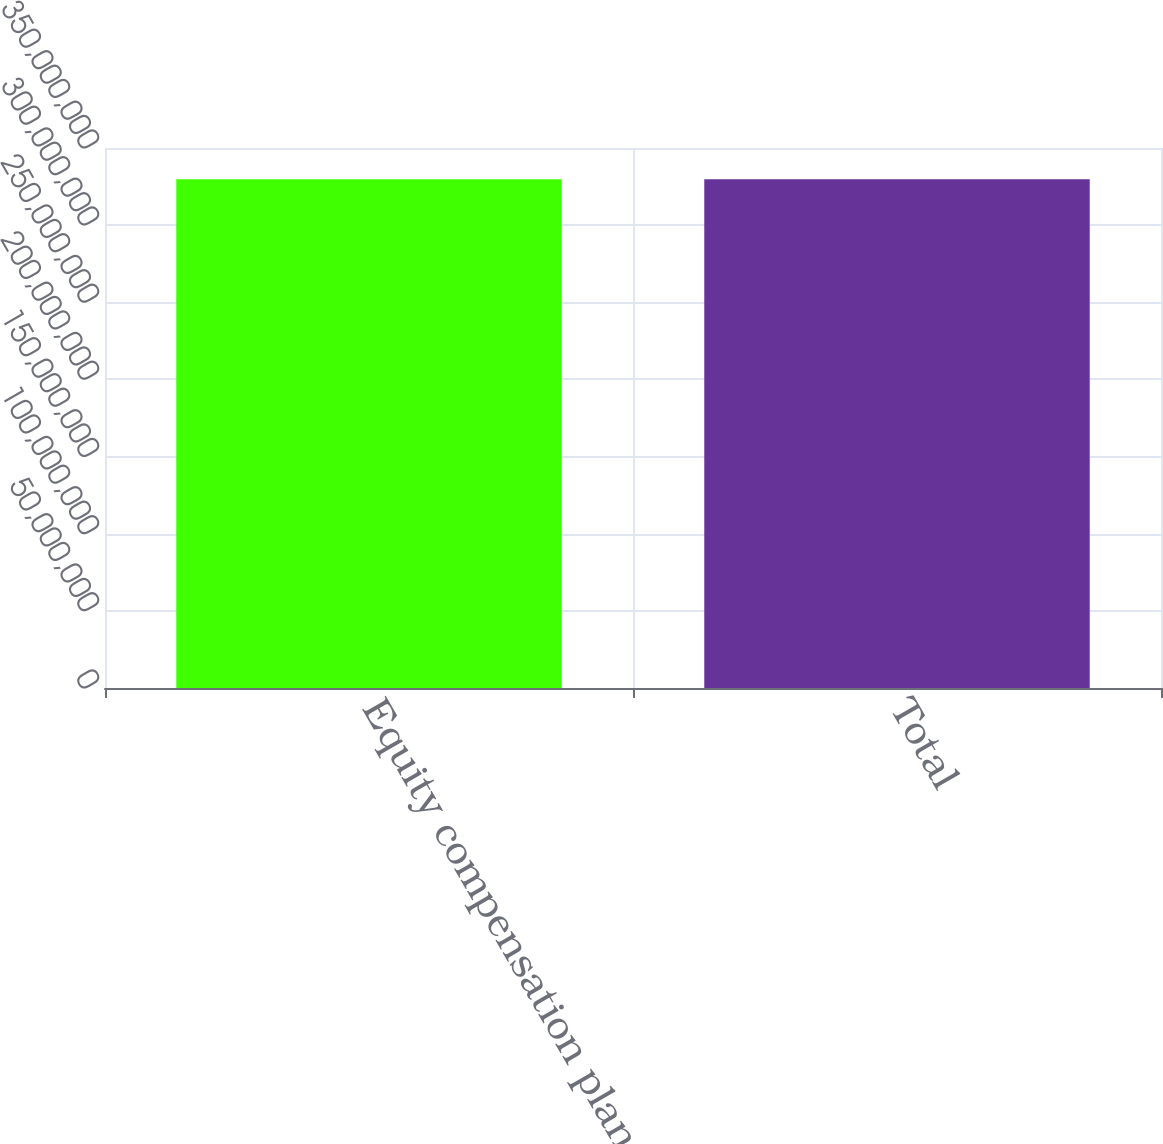Convert chart. <chart><loc_0><loc_0><loc_500><loc_500><bar_chart><fcel>Equity compensation plans<fcel>Total<nl><fcel>3.297e+08<fcel>3.297e+08<nl></chart> 